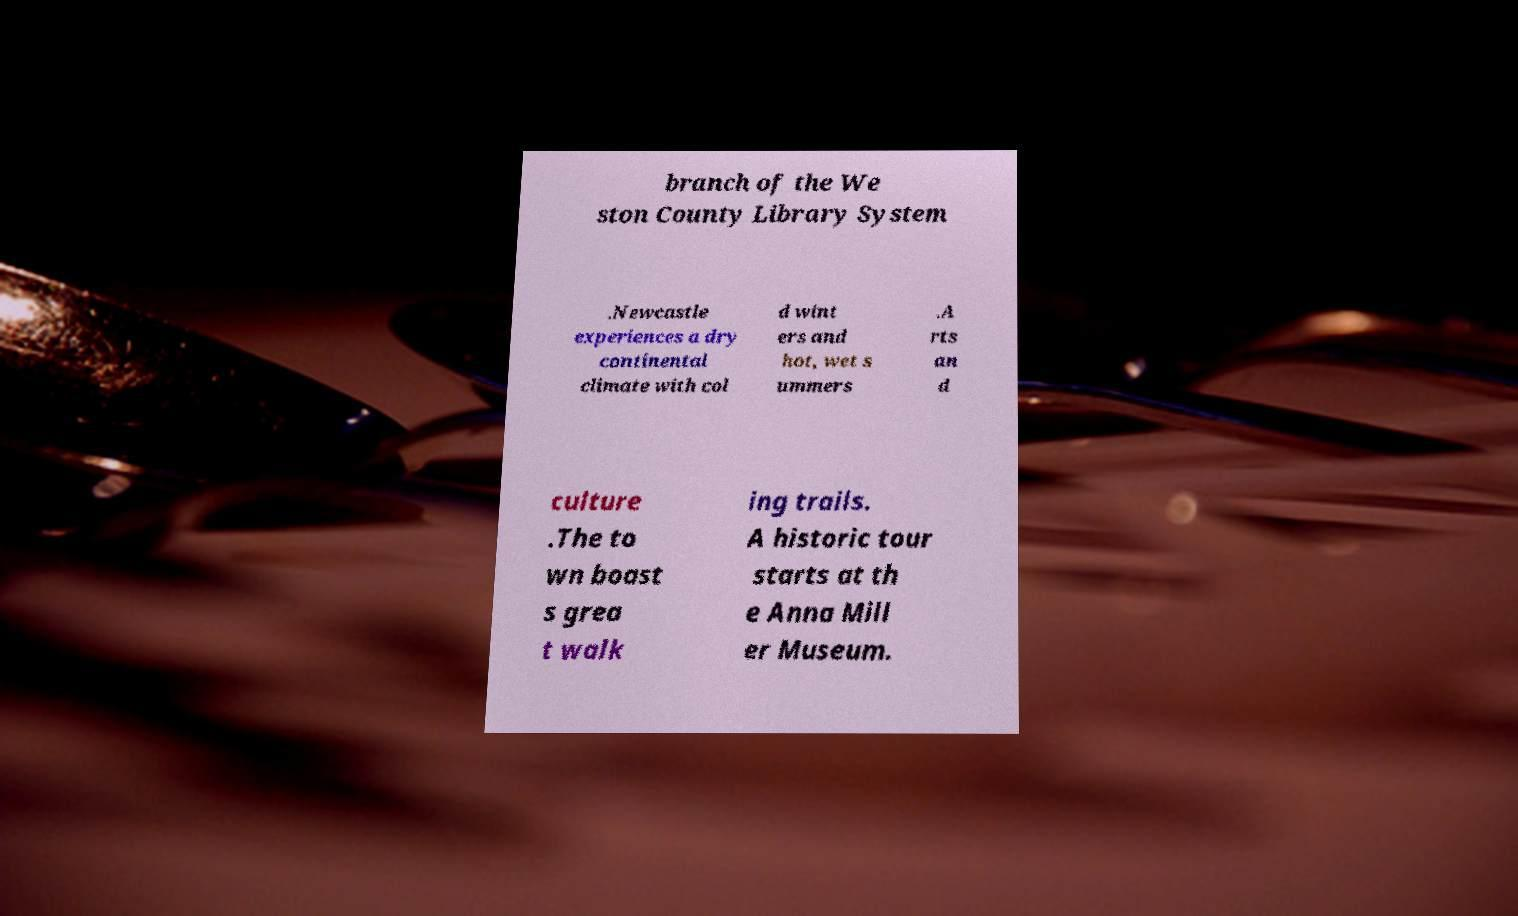For documentation purposes, I need the text within this image transcribed. Could you provide that? branch of the We ston County Library System .Newcastle experiences a dry continental climate with col d wint ers and hot, wet s ummers .A rts an d culture .The to wn boast s grea t walk ing trails. A historic tour starts at th e Anna Mill er Museum. 